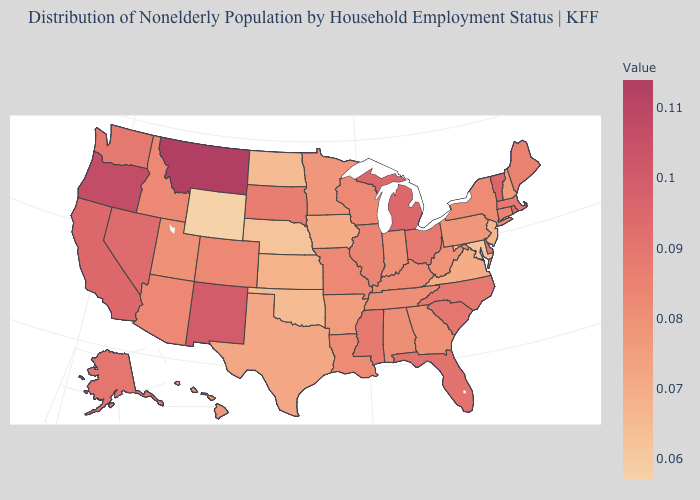Does Kentucky have a lower value than Alaska?
Answer briefly. Yes. Is the legend a continuous bar?
Answer briefly. Yes. Does Georgia have the lowest value in the South?
Answer briefly. No. Among the states that border New Mexico , which have the lowest value?
Write a very short answer. Oklahoma. Does Illinois have the highest value in the MidWest?
Quick response, please. No. Does New Jersey have the lowest value in the Northeast?
Be succinct. Yes. Does New Hampshire have the lowest value in the USA?
Give a very brief answer. No. 